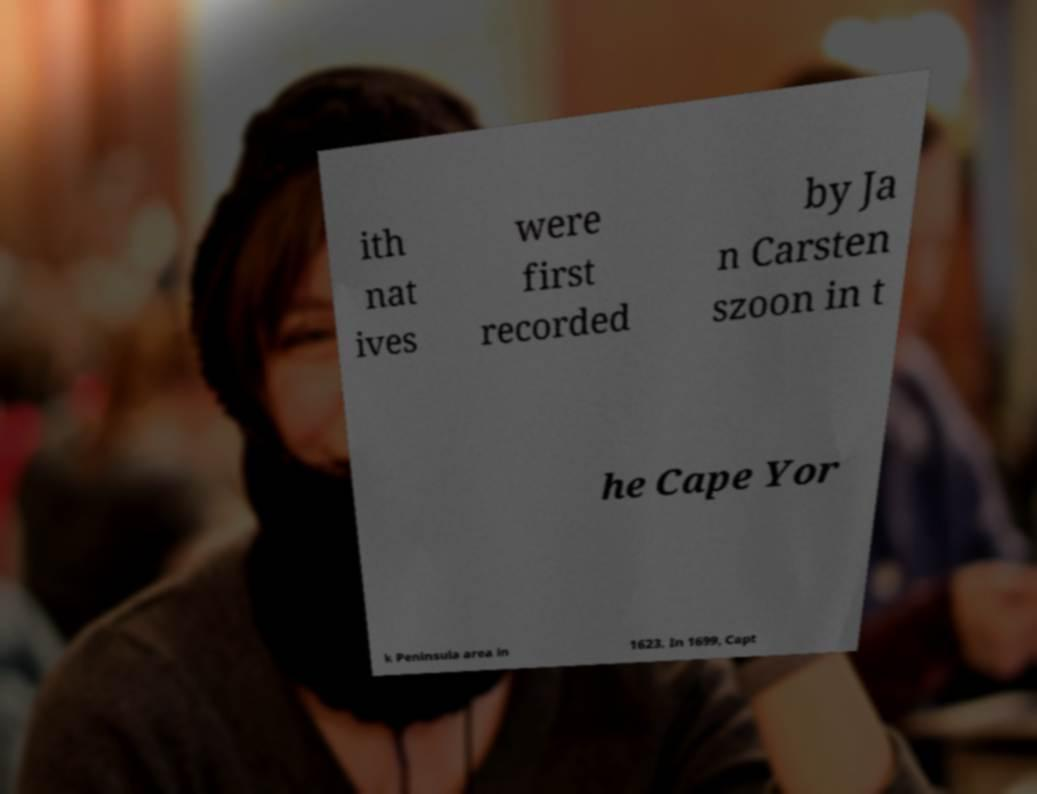Please read and relay the text visible in this image. What does it say? ith nat ives were first recorded by Ja n Carsten szoon in t he Cape Yor k Peninsula area in 1623. In 1699, Capt 